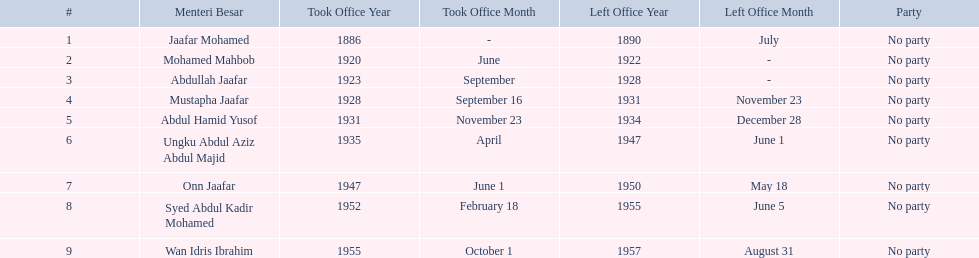What are all the people that were menteri besar of johor? Jaafar Mohamed, Mohamed Mahbob, Abdullah Jaafar, Mustapha Jaafar, Abdul Hamid Yusof, Ungku Abdul Aziz Abdul Majid, Onn Jaafar, Syed Abdul Kadir Mohamed, Wan Idris Ibrahim. Who ruled the longest? Ungku Abdul Aziz Abdul Majid. 